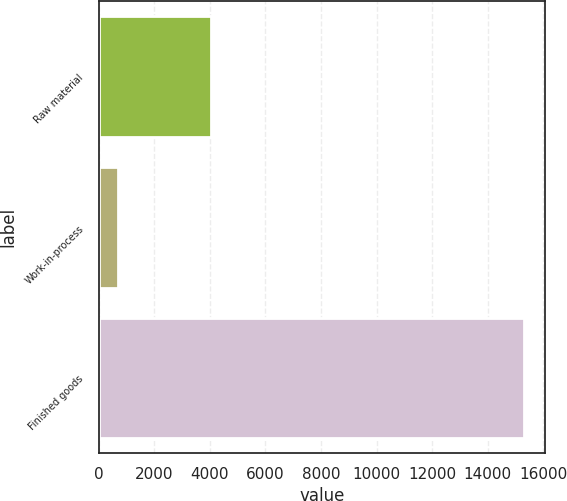Convert chart. <chart><loc_0><loc_0><loc_500><loc_500><bar_chart><fcel>Raw material<fcel>Work-in-process<fcel>Finished goods<nl><fcel>4028<fcel>702<fcel>15295<nl></chart> 